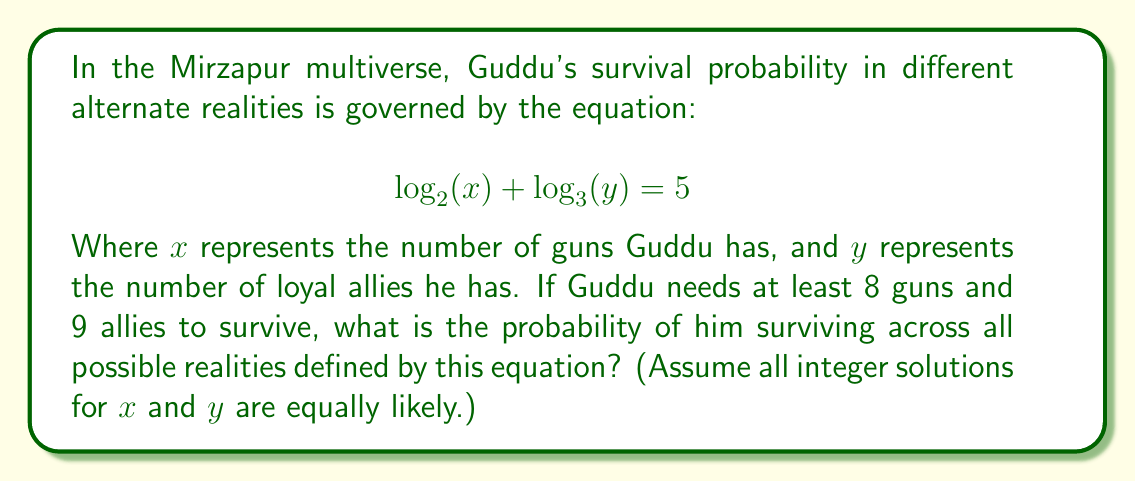What is the answer to this math problem? Let's approach this step-by-step:

1) First, we need to solve the equation for all possible integer values of $x$ and $y$.

2) We can rewrite the equation as:
   $$ 2^{\log_2(x)} \cdot 3^{\log_3(y)} = 2^5 = 32 $$

3) This simplifies to:
   $$ xy = 32 $$

4) The integer factors of 32 are: 1, 2, 4, 8, 16, 32

5) So, the possible (x, y) pairs are:
   (1, 32), (2, 16), (4, 8), (8, 4), (16, 2), (32, 1)

6) However, Guddu needs at least 8 guns and 9 allies to survive. The only pair that satisfies this is (16, 2).

7) To calculate the probability, we need to determine how many of the total possibilities meet our criteria:

   Favorable outcomes: 1
   Total outcomes: 6

8) Therefore, the probability is:
   $$ P(\text{survival}) = \frac{1}{6} $$
Answer: The probability of Guddu surviving across all possible realities defined by the equation is $\frac{1}{6}$ or approximately 0.1667 or 16.67%. 